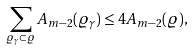<formula> <loc_0><loc_0><loc_500><loc_500>\sum _ { \varrho _ { \gamma } \subset \varrho } A _ { m - 2 } ( \varrho _ { \gamma } ) \leq 4 A _ { m - 2 } ( \varrho ) ,</formula> 